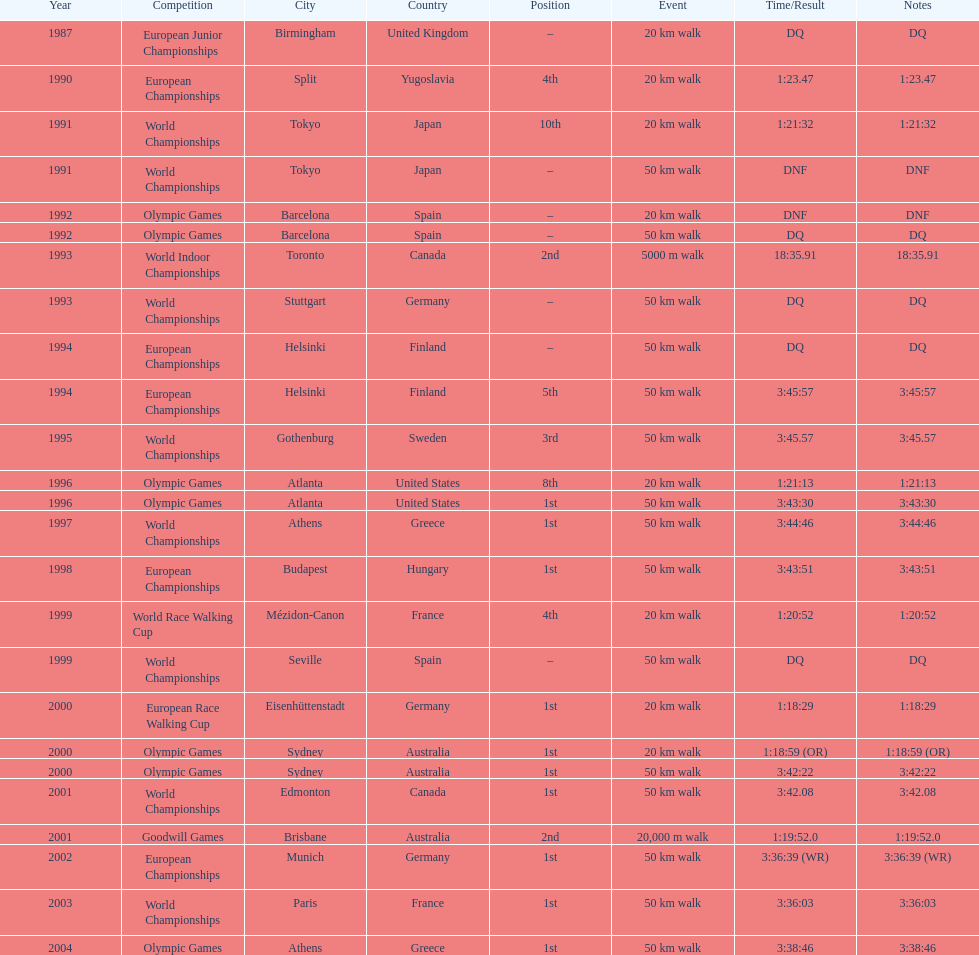How many times did korzeniowski finish above fourth place? 13. Can you give me this table as a dict? {'header': ['Year', 'Competition', 'City', 'Country', 'Position', 'Event', 'Time/Result', 'Notes'], 'rows': [['1987', 'European Junior Championships', 'Birmingham', 'United Kingdom', '–', '20\xa0km walk', 'DQ', 'DQ'], ['1990', 'European Championships', 'Split', 'Yugoslavia', '4th', '20\xa0km walk', '1:23.47', '1:23.47'], ['1991', 'World Championships', 'Tokyo', 'Japan', '10th', '20\xa0km walk', '1:21:32', '1:21:32'], ['1991', 'World Championships', 'Tokyo', 'Japan', '–', '50\xa0km walk', 'DNF', 'DNF'], ['1992', 'Olympic Games', 'Barcelona', 'Spain', '–', '20\xa0km walk', 'DNF', 'DNF'], ['1992', 'Olympic Games', 'Barcelona', 'Spain', '–', '50\xa0km walk', 'DQ', 'DQ'], ['1993', 'World Indoor Championships', 'Toronto', 'Canada', '2nd', '5000 m walk', '18:35.91', '18:35.91'], ['1993', 'World Championships', 'Stuttgart', 'Germany', '–', '50\xa0km walk', 'DQ', 'DQ'], ['1994', 'European Championships', 'Helsinki', 'Finland', '–', '50\xa0km walk', 'DQ', 'DQ'], ['1994', 'European Championships', 'Helsinki', 'Finland', '5th', '50\xa0km walk', '3:45:57', '3:45:57'], ['1995', 'World Championships', 'Gothenburg', 'Sweden', '3rd', '50\xa0km walk', '3:45.57', '3:45.57'], ['1996', 'Olympic Games', 'Atlanta', 'United States', '8th', '20\xa0km walk', '1:21:13', '1:21:13'], ['1996', 'Olympic Games', 'Atlanta', 'United States', '1st', '50\xa0km walk', '3:43:30', '3:43:30'], ['1997', 'World Championships', 'Athens', 'Greece', '1st', '50\xa0km walk', '3:44:46', '3:44:46'], ['1998', 'European Championships', 'Budapest', 'Hungary', '1st', '50\xa0km walk', '3:43:51', '3:43:51'], ['1999', 'World Race Walking Cup', 'Mézidon-Canon', 'France', '4th', '20\xa0km walk', '1:20:52', '1:20:52'], ['1999', 'World Championships', 'Seville', 'Spain', '–', '50\xa0km walk', 'DQ', 'DQ'], ['2000', 'European Race Walking Cup', 'Eisenhüttenstadt', 'Germany', '1st', '20\xa0km walk', '1:18:29', '1:18:29'], ['2000', 'Olympic Games', 'Sydney', 'Australia', '1st', '20\xa0km walk', '1:18:59 (OR)', '1:18:59 (OR)'], ['2000', 'Olympic Games', 'Sydney', 'Australia', '1st', '50\xa0km walk', '3:42:22', '3:42:22'], ['2001', 'World Championships', 'Edmonton', 'Canada', '1st', '50\xa0km walk', '3:42.08', '3:42.08'], ['2001', 'Goodwill Games', 'Brisbane', 'Australia', '2nd', '20,000 m walk', '1:19:52.0', '1:19:52.0'], ['2002', 'European Championships', 'Munich', 'Germany', '1st', '50\xa0km walk', '3:36:39 (WR)', '3:36:39 (WR)'], ['2003', 'World Championships', 'Paris', 'France', '1st', '50\xa0km walk', '3:36:03', '3:36:03'], ['2004', 'Olympic Games', 'Athens', 'Greece', '1st', '50\xa0km walk', '3:38:46', '3:38:46']]} 